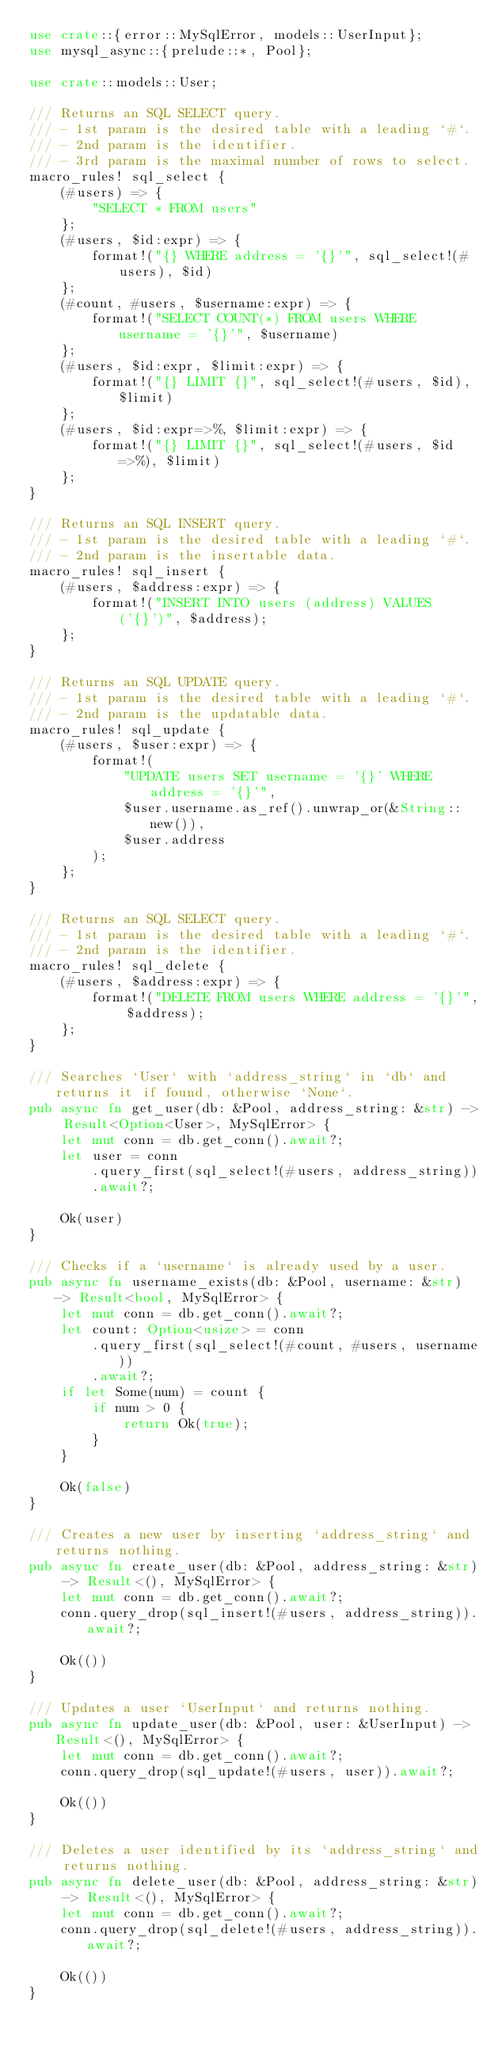<code> <loc_0><loc_0><loc_500><loc_500><_Rust_>use crate::{error::MySqlError, models::UserInput};
use mysql_async::{prelude::*, Pool};

use crate::models::User;

/// Returns an SQL SELECT query.
/// - 1st param is the desired table with a leading `#`.
/// - 2nd param is the identifier.
/// - 3rd param is the maximal number of rows to select.
macro_rules! sql_select {
    (#users) => {
        "SELECT * FROM users"
    };
    (#users, $id:expr) => {
        format!("{} WHERE address = '{}'", sql_select!(#users), $id)
    };
    (#count, #users, $username:expr) => {
        format!("SELECT COUNT(*) FROM users WHERE username = '{}'", $username)
    };
    (#users, $id:expr, $limit:expr) => {
        format!("{} LIMIT {}", sql_select!(#users, $id), $limit)
    };
    (#users, $id:expr=>%, $limit:expr) => {
        format!("{} LIMIT {}", sql_select!(#users, $id=>%), $limit)
    };
}

/// Returns an SQL INSERT query.
/// - 1st param is the desired table with a leading `#`.
/// - 2nd param is the insertable data.
macro_rules! sql_insert {
    (#users, $address:expr) => {
        format!("INSERT INTO users (address) VALUES ('{}')", $address);
    };
}

/// Returns an SQL UPDATE query.
/// - 1st param is the desired table with a leading `#`.
/// - 2nd param is the updatable data.
macro_rules! sql_update {
    (#users, $user:expr) => {
        format!(
            "UPDATE users SET username = '{}' WHERE address = '{}'",
            $user.username.as_ref().unwrap_or(&String::new()),
            $user.address
        );
    };
}

/// Returns an SQL SELECT query.
/// - 1st param is the desired table with a leading `#`.
/// - 2nd param is the identifier.
macro_rules! sql_delete {
    (#users, $address:expr) => {
        format!("DELETE FROM users WHERE address = '{}'", $address);
    };
}

/// Searches `User` with `address_string` in `db` and returns it if found, otherwise `None`.
pub async fn get_user(db: &Pool, address_string: &str) -> Result<Option<User>, MySqlError> {
    let mut conn = db.get_conn().await?;
    let user = conn
        .query_first(sql_select!(#users, address_string))
        .await?;

    Ok(user)
}

/// Checks if a `username` is already used by a user.
pub async fn username_exists(db: &Pool, username: &str) -> Result<bool, MySqlError> {
    let mut conn = db.get_conn().await?;
    let count: Option<usize> = conn
        .query_first(sql_select!(#count, #users, username))
        .await?;
    if let Some(num) = count {
        if num > 0 {
            return Ok(true);
        }
    }

    Ok(false)
}

/// Creates a new user by inserting `address_string` and returns nothing.
pub async fn create_user(db: &Pool, address_string: &str) -> Result<(), MySqlError> {
    let mut conn = db.get_conn().await?;
    conn.query_drop(sql_insert!(#users, address_string)).await?;

    Ok(())
}

/// Updates a user `UserInput` and returns nothing.
pub async fn update_user(db: &Pool, user: &UserInput) -> Result<(), MySqlError> {
    let mut conn = db.get_conn().await?;
    conn.query_drop(sql_update!(#users, user)).await?;

    Ok(())
}

/// Deletes a user identified by its `address_string` and returns nothing.
pub async fn delete_user(db: &Pool, address_string: &str) -> Result<(), MySqlError> {
    let mut conn = db.get_conn().await?;
    conn.query_drop(sql_delete!(#users, address_string)).await?;

    Ok(())
}
</code> 